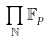Convert formula to latex. <formula><loc_0><loc_0><loc_500><loc_500>\prod _ { \mathbb { N } } \mathbb { F } _ { p }</formula> 